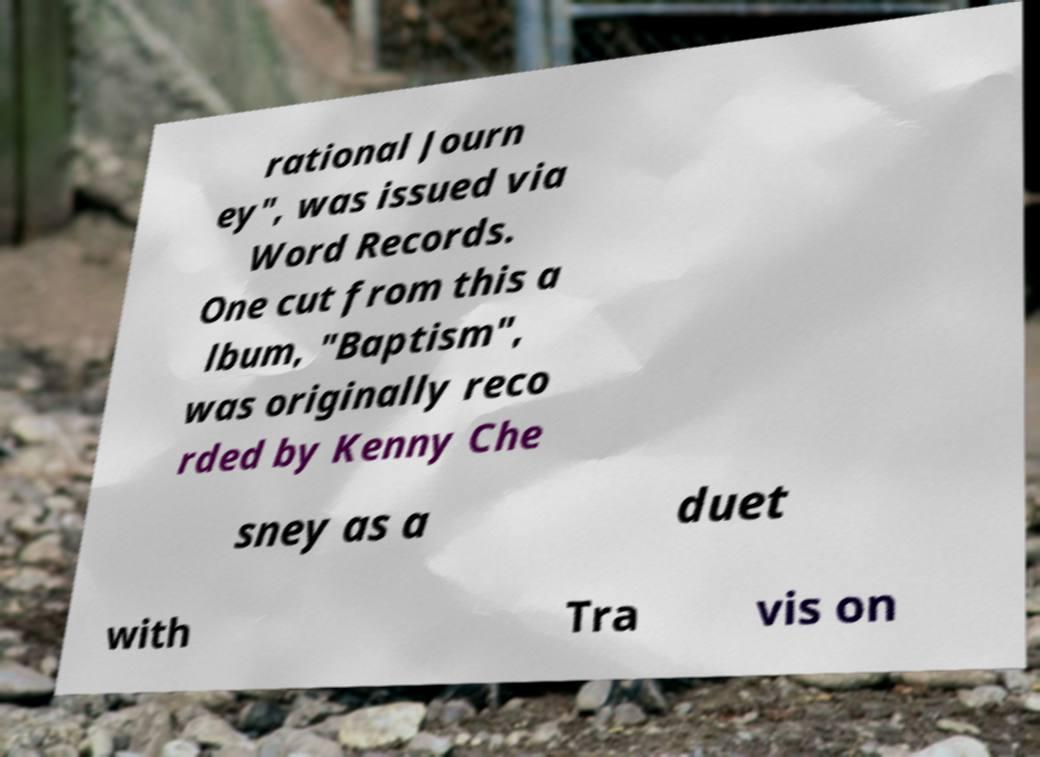What messages or text are displayed in this image? I need them in a readable, typed format. rational Journ ey", was issued via Word Records. One cut from this a lbum, "Baptism", was originally reco rded by Kenny Che sney as a duet with Tra vis on 